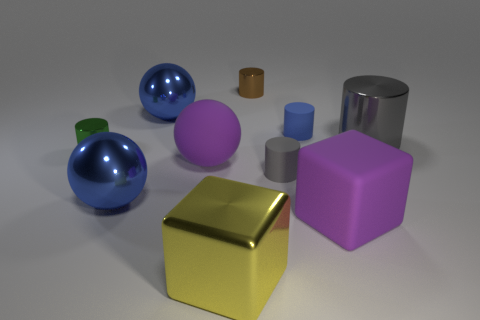Subtract all blue cylinders. How many cylinders are left? 4 Subtract all green cylinders. How many cylinders are left? 4 Subtract all green cylinders. Subtract all blue balls. How many cylinders are left? 4 Subtract all blocks. How many objects are left? 8 Add 1 matte things. How many matte things are left? 5 Add 9 gray shiny things. How many gray shiny things exist? 10 Subtract 0 brown blocks. How many objects are left? 10 Subtract all blue metal things. Subtract all small gray objects. How many objects are left? 7 